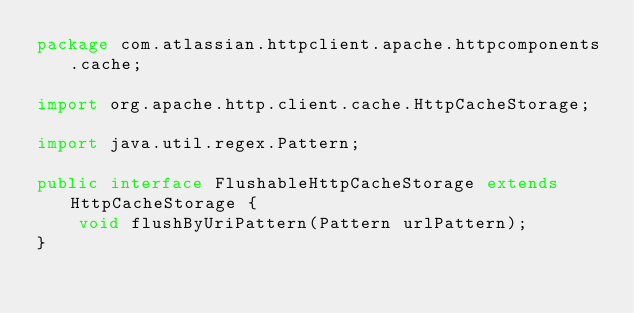Convert code to text. <code><loc_0><loc_0><loc_500><loc_500><_Java_>package com.atlassian.httpclient.apache.httpcomponents.cache;

import org.apache.http.client.cache.HttpCacheStorage;

import java.util.regex.Pattern;

public interface FlushableHttpCacheStorage extends HttpCacheStorage {
    void flushByUriPattern(Pattern urlPattern);
}
</code> 